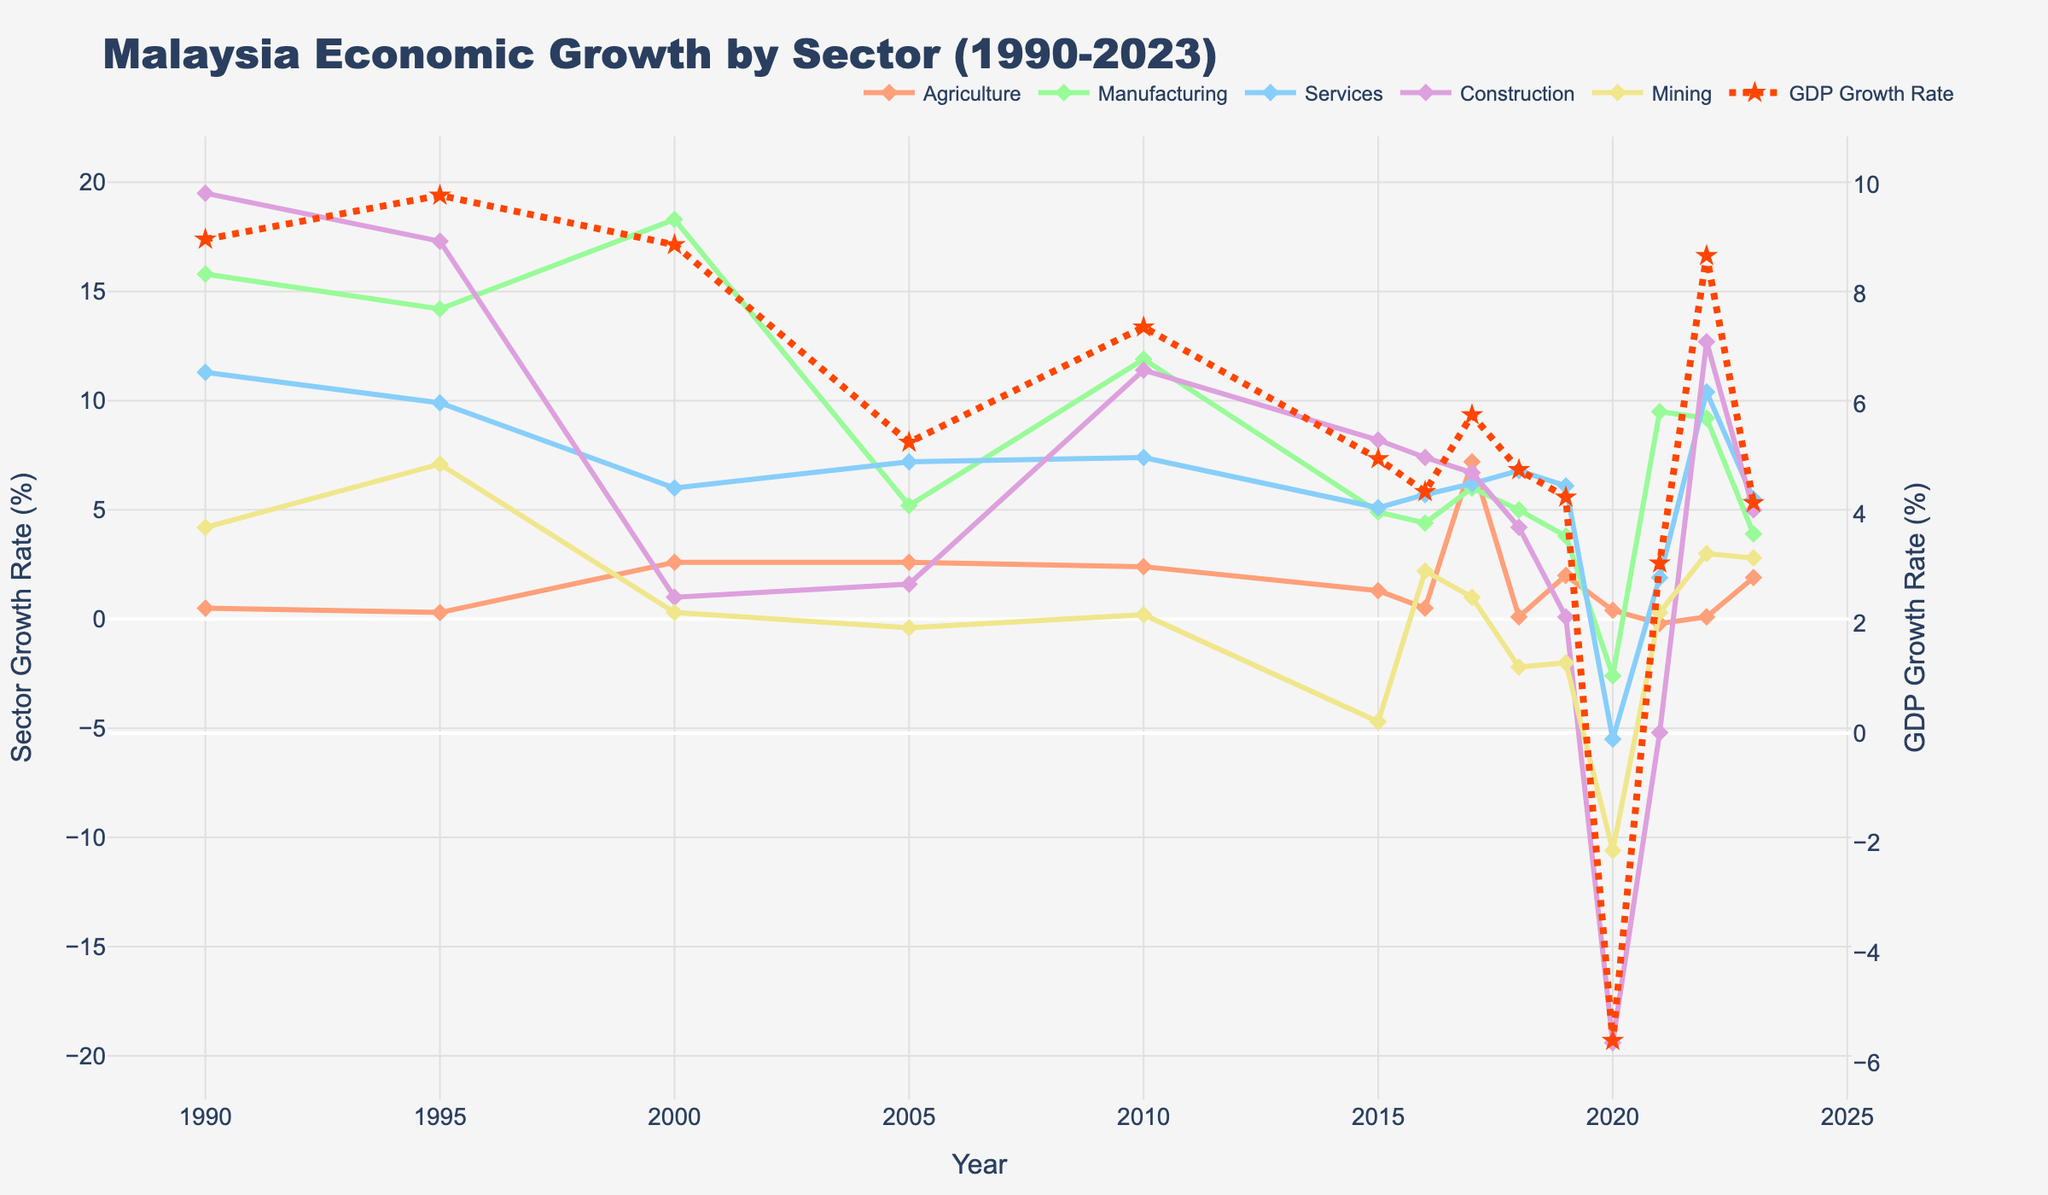What sector showed the most growth in 2010? To find the sector with the most growth in 2010, look at the y-values for each sector in 2010. The highest y-value indicates the sector with the most growth. For 2010, Manufacturing grew the most.
Answer: Manufacturing Which year had the highest GDP growth rate, and what was the rate? Look at the highest point on the GDP Growth Rate line. Identify the x-axis value (year) and the y-axis value (growth rate). The highest GDP growth rate is in 1995, with a rate of 9.8%.
Answer: 1995, 9.8% During which years did the Services sector have higher growth than the Agriculture sector? Compare the Services and Agriculture growth rates year by year. Highlight the years where the y-value of Services is greater than the y-value of Agriculture. For years 2000, 2005, 2010, 2015, 2016, 2018, 2019, 2020, 2021, 2022, and 2023, Services has higher growth.
Answer: 2000, 2005, 2010, 2015, 2016, 2018, 2019, 2020, 2021, 2022, 2023 How did the GDP growth rate in 2022 compare to that in 2021? Look at the GDP Growth Rate line for 2021 and 2022. The y-value in 2022 is 8.7%, and in 2021 it is 3.1%. Thus, 2022's rate is higher.
Answer: 2022 is higher Between 1995 and 2000, which sector experienced the most significant decrease in growth, and by how much? Subtract the 1995 growth rate from the 2000 growth rate for each sector to find the differences. The sector with the biggest negative difference experienced the most significant decrease. Mining had the biggest decrease: 7.1 - 0.3 = 6.8.
Answer: Mining, 6.8% What was the overall trend of Malaysia’s GDP growth rate from 1990 to 2023? Observe the general direction of the GDP Growth Rate line from 1990 to 2023. Initiate from the early peaks around 1990 and 1995, the mid-period slowdown, recovery phases, and the sharp drop in 2020, conclude with recent recovery by 2022.
Answer: Fluctuating with a peak in the 1990s, a decline mid-period, and a recovery peaking in 2022 Which sector had positive growth in 2020 despite the overall negative GDP growth rate? Inspect the y-values associated with each sector in 2020 and identify the sectors with positive values. Construction also had a substantially negative rate; hence, Mining appears positive amidst other negatives.
Answer: Mining Compare the growth rate of Construction and Manufacturing in 2022. Which was higher? Look at the y-values for Construction and Manufacturing for 2022. Construction has a growth rate of 12.7%, whereas Manufacturing has 9.2%. Construction is higher.
Answer: Construction In which years did both Agriculture and Mining sectors experience a decline? Examine years where both the Agriculture and Mining sector lines have negative values. This occurred in years 2021, 2018, 2015, and 2005.
Answer: 2021, 2018, 2015, 2005 